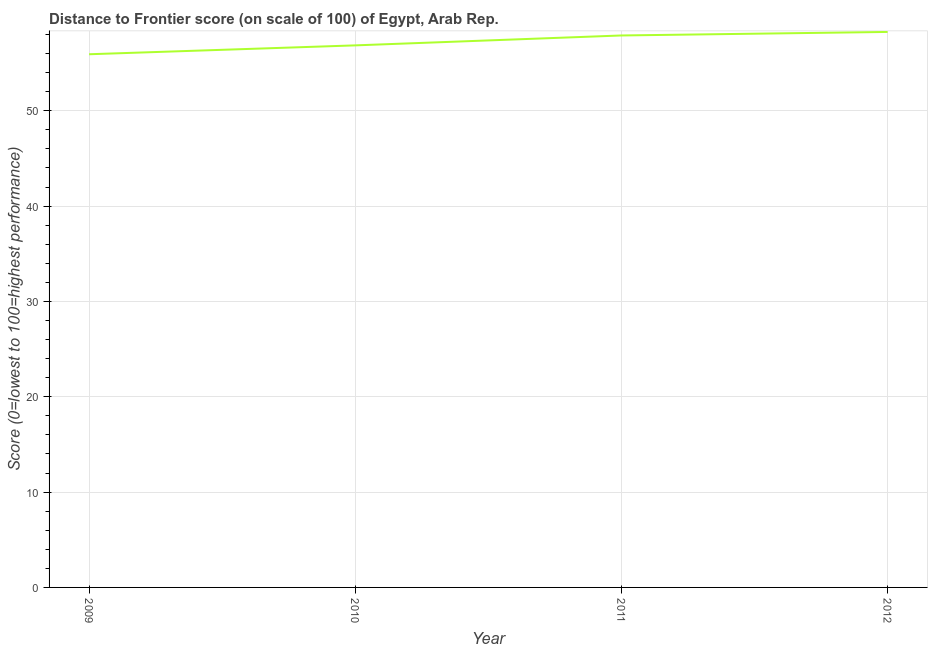What is the distance to frontier score in 2010?
Provide a short and direct response. 56.86. Across all years, what is the maximum distance to frontier score?
Ensure brevity in your answer.  58.27. Across all years, what is the minimum distance to frontier score?
Your response must be concise. 55.93. In which year was the distance to frontier score minimum?
Make the answer very short. 2009. What is the sum of the distance to frontier score?
Make the answer very short. 228.96. What is the difference between the distance to frontier score in 2011 and 2012?
Your response must be concise. -0.37. What is the average distance to frontier score per year?
Your answer should be very brief. 57.24. What is the median distance to frontier score?
Offer a very short reply. 57.38. What is the ratio of the distance to frontier score in 2010 to that in 2011?
Your answer should be compact. 0.98. Is the distance to frontier score in 2010 less than that in 2012?
Give a very brief answer. Yes. Is the difference between the distance to frontier score in 2010 and 2011 greater than the difference between any two years?
Make the answer very short. No. What is the difference between the highest and the second highest distance to frontier score?
Ensure brevity in your answer.  0.37. Is the sum of the distance to frontier score in 2009 and 2010 greater than the maximum distance to frontier score across all years?
Your answer should be compact. Yes. What is the difference between the highest and the lowest distance to frontier score?
Your answer should be compact. 2.34. How many years are there in the graph?
Your answer should be compact. 4. Does the graph contain any zero values?
Keep it short and to the point. No. Does the graph contain grids?
Your answer should be very brief. Yes. What is the title of the graph?
Provide a short and direct response. Distance to Frontier score (on scale of 100) of Egypt, Arab Rep. What is the label or title of the Y-axis?
Your answer should be very brief. Score (0=lowest to 100=highest performance). What is the Score (0=lowest to 100=highest performance) in 2009?
Keep it short and to the point. 55.93. What is the Score (0=lowest to 100=highest performance) in 2010?
Offer a terse response. 56.86. What is the Score (0=lowest to 100=highest performance) in 2011?
Make the answer very short. 57.9. What is the Score (0=lowest to 100=highest performance) of 2012?
Ensure brevity in your answer.  58.27. What is the difference between the Score (0=lowest to 100=highest performance) in 2009 and 2010?
Keep it short and to the point. -0.93. What is the difference between the Score (0=lowest to 100=highest performance) in 2009 and 2011?
Offer a terse response. -1.97. What is the difference between the Score (0=lowest to 100=highest performance) in 2009 and 2012?
Ensure brevity in your answer.  -2.34. What is the difference between the Score (0=lowest to 100=highest performance) in 2010 and 2011?
Offer a very short reply. -1.04. What is the difference between the Score (0=lowest to 100=highest performance) in 2010 and 2012?
Keep it short and to the point. -1.41. What is the difference between the Score (0=lowest to 100=highest performance) in 2011 and 2012?
Your response must be concise. -0.37. What is the ratio of the Score (0=lowest to 100=highest performance) in 2009 to that in 2011?
Your answer should be very brief. 0.97. What is the ratio of the Score (0=lowest to 100=highest performance) in 2011 to that in 2012?
Offer a terse response. 0.99. 